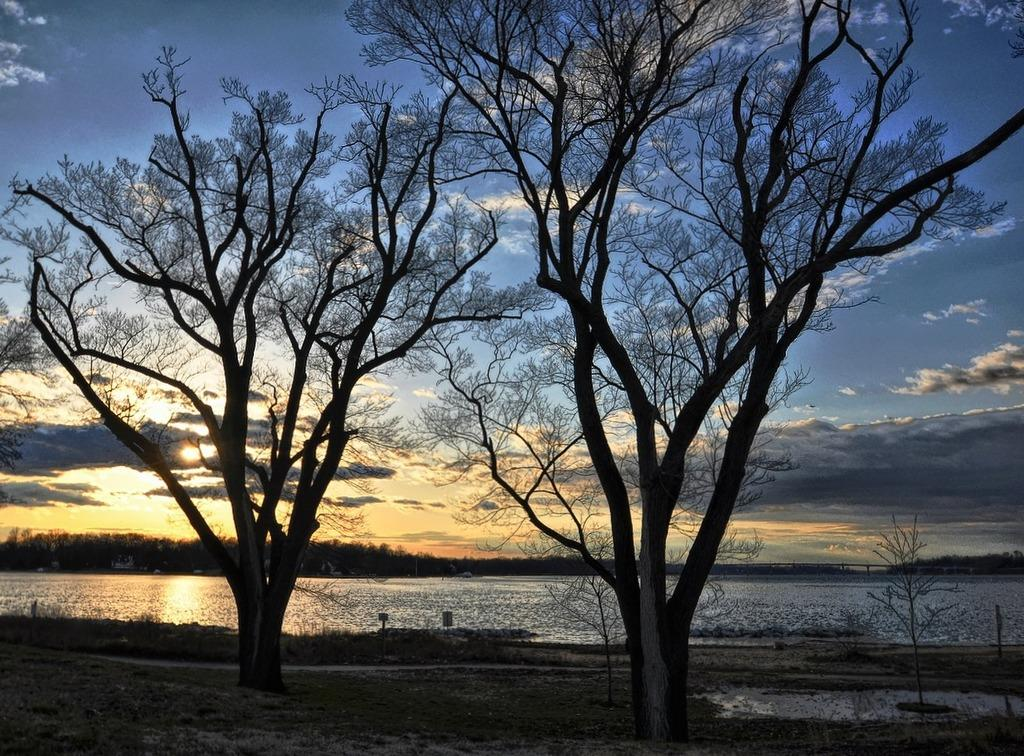What type of vegetation can be seen in the image? There are trees in the image. What is visible in the background of the image? The background of the image includes water. What part of the natural environment is visible in the image? The sky is visible in the image. What colors are present in the sky? The sky has blue and white colors. What time does the clock show in the image? There is no clock present in the image. How many geese are swimming in the water in the image? There are no geese present in the image; the background only includes water. 